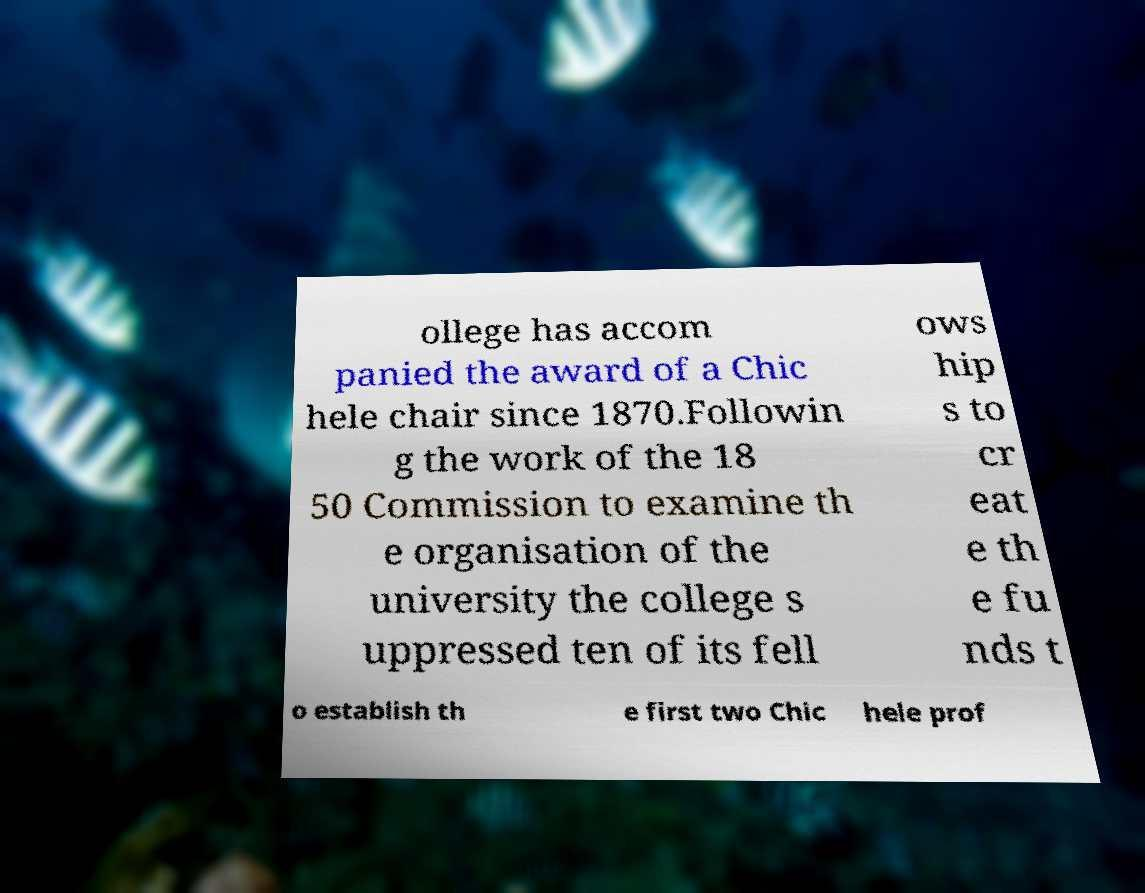Please identify and transcribe the text found in this image. ollege has accom panied the award of a Chic hele chair since 1870.Followin g the work of the 18 50 Commission to examine th e organisation of the university the college s uppressed ten of its fell ows hip s to cr eat e th e fu nds t o establish th e first two Chic hele prof 